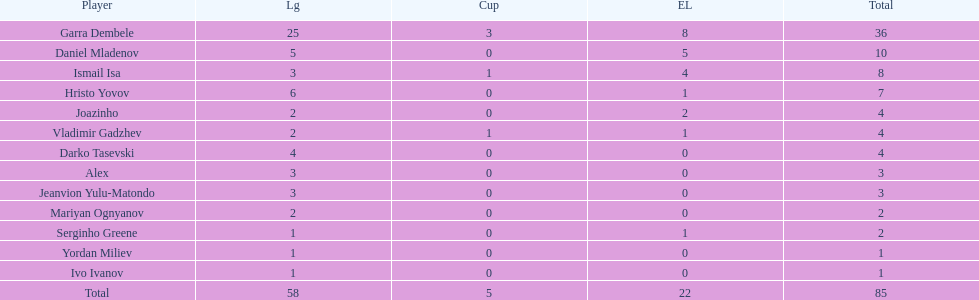Which players have at least 4 in the europa league? Garra Dembele, Daniel Mladenov, Ismail Isa. 